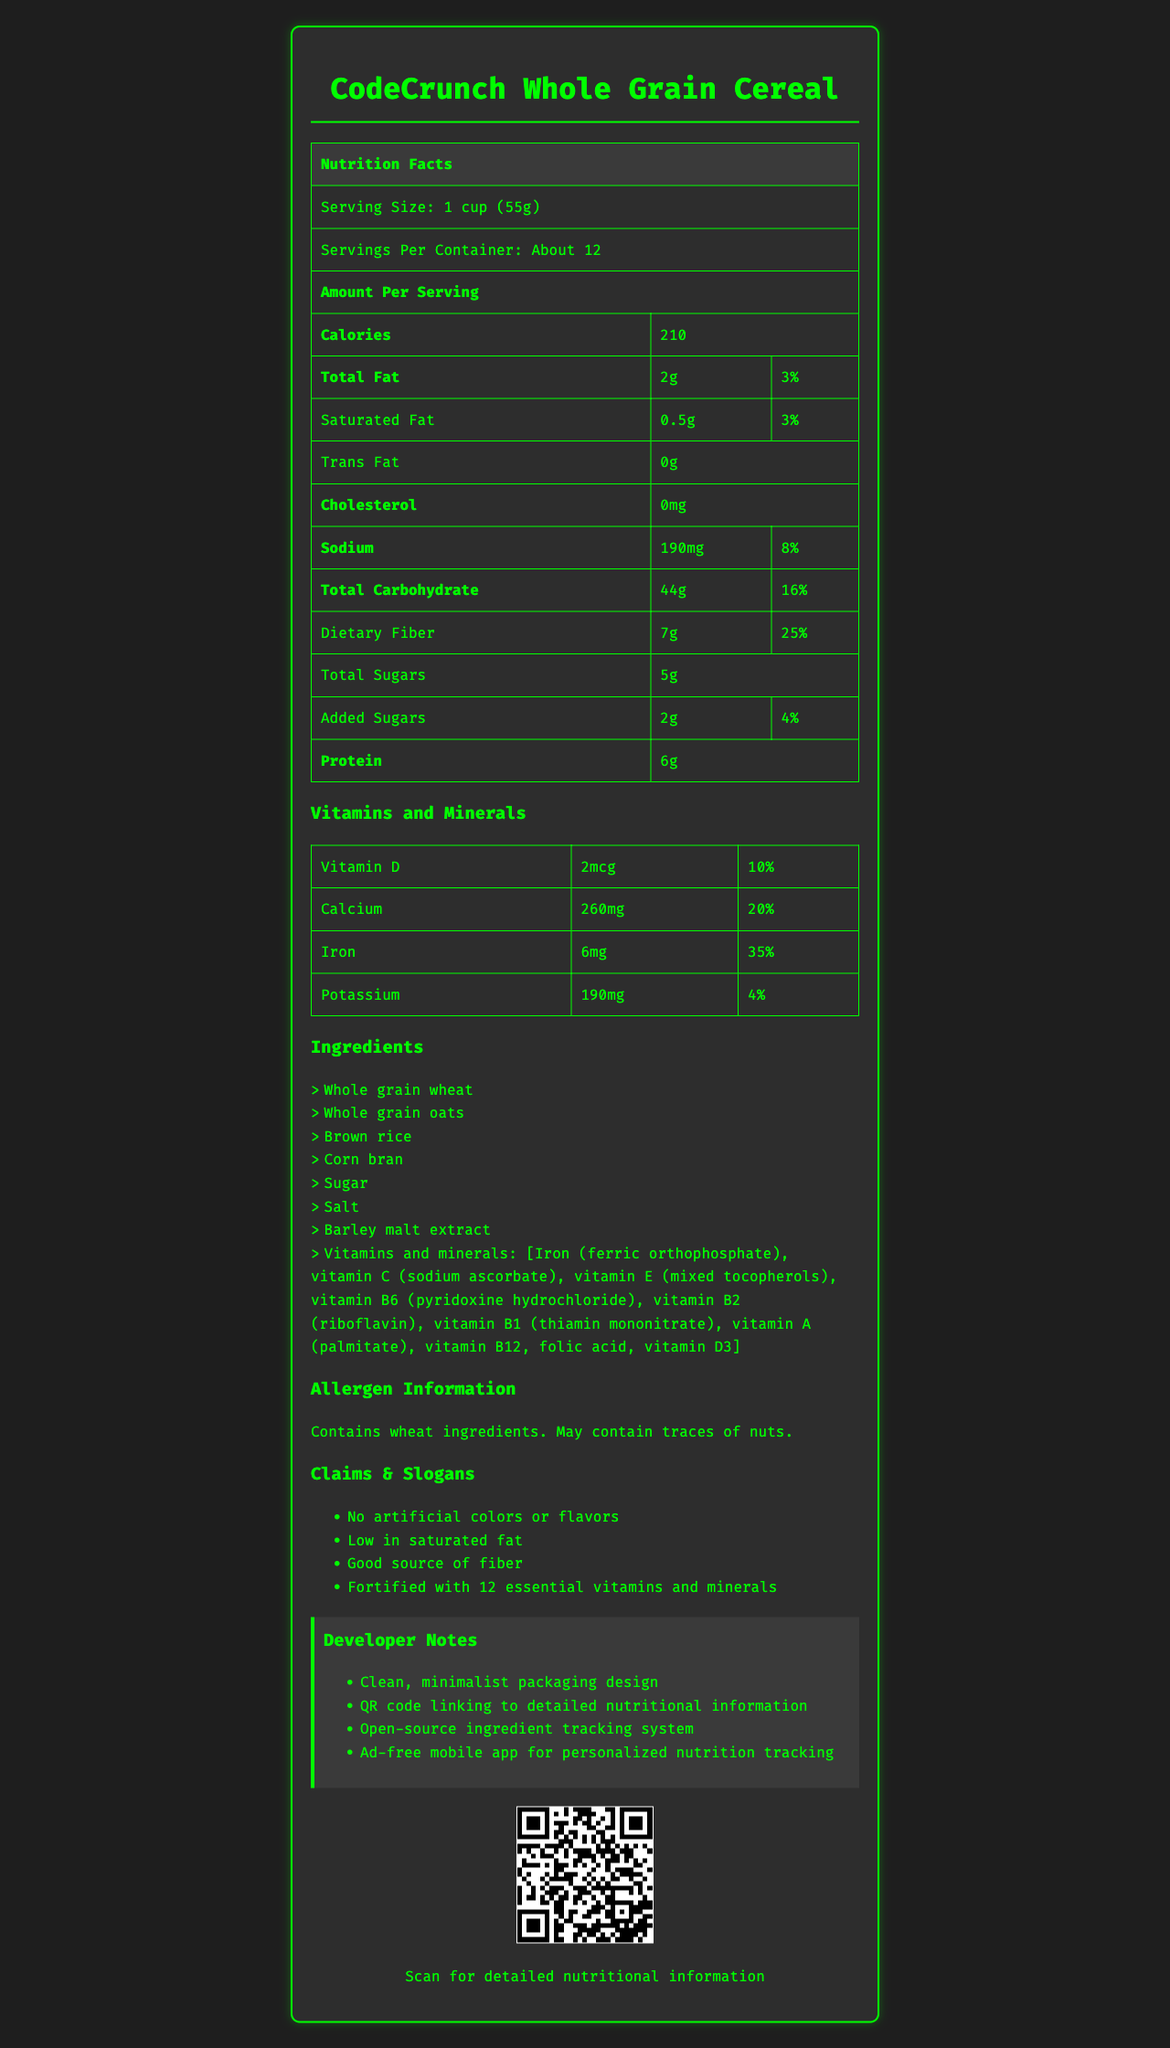what is the serving size for CodeCrunch Whole Grain Cereal? The serving size is listed at the top of the Nutrition Facts label as "1 cup (55g)".
Answer: 1 cup (55g) how many calories are in one serving of CodeCrunch Whole Grain Cereal? The number of calories per serving is provided in the "Amount Per Serving" section of the label as 210 calories.
Answer: 210 what is the total fat content per serving, and its daily value percentage? The total fat content is given as 2g, which is 3% of the daily value.
Answer: 2g, 3% how much iron is in one serving, and what percentage of the daily value is it? The iron content is listed as 6mg, which equals 35% of the daily value.
Answer: 6mg, 35% what claims and slogans are associated with CodeCrunch Whole Grain Cereal? These claims are listed under the "Claims & Slogans" section at the bottom of the document.
Answer: No artificial colors or flavors, Low in saturated fat, Good source of fiber, Fortified with 12 essential vitamins and minerals how many servings are there per container of CodeCrunch Whole Grain Cereal?
multiple-choice: 
1. About 10
2. About 12
3. About 15 The number of servings per container is "About 12," listed at the top of the Nutrition Facts section.
Answer: 2 is there any cholesterol in CodeCrunch Whole Grain Cereal? The cholesterol content is listed as "0mg," indicating there is no cholesterol.
Answer: No does the product include any nuts in its ingredients? The allergen information states, "Contains wheat ingredients. May contain traces of nuts."
Answer: May contain traces of nuts. describe the main idea of the document The document serves as an all-inclusive label for CodeCrunch Whole Grain Cereal, showcasing its nutritional benefits, ingredient details, and product-related claims to inform potential consumers.
Answer: The document provides detailed nutritional information for CodeCrunch Whole Grain Cereal, including serving size, calories, fats, vitamins, and minerals. It also lists the ingredients, allergen information, and marketing claims. Additional features like developer notes and a QR code for more information are also highlighted. what is the source of fiber in CodeCrunch Whole Grain Cereal? The document lists ingredients and mentions that the cereal is a good source of fiber, but it does not specify which ingredient(s) specifically provide the fiber.
Answer: Cannot be determined 